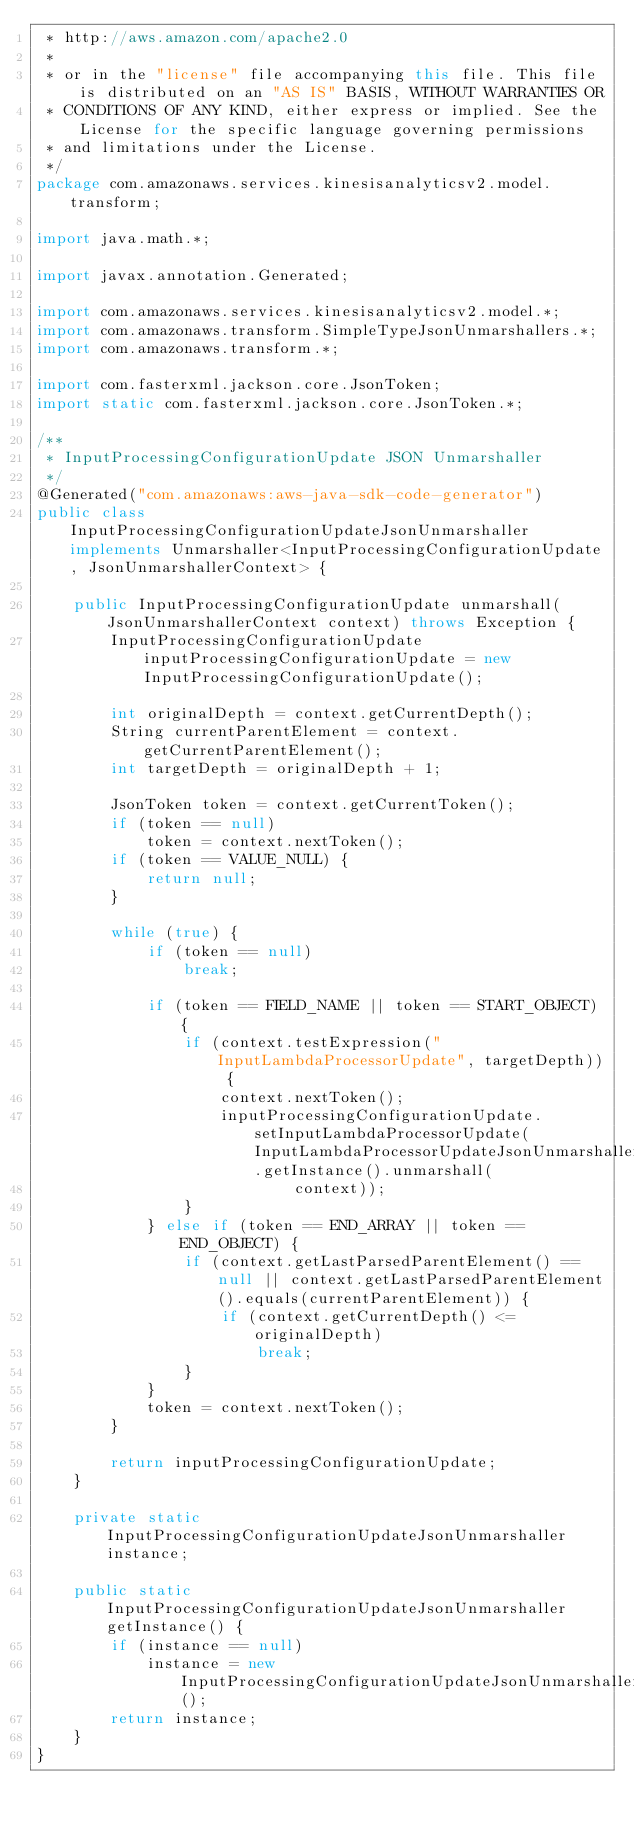Convert code to text. <code><loc_0><loc_0><loc_500><loc_500><_Java_> * http://aws.amazon.com/apache2.0
 * 
 * or in the "license" file accompanying this file. This file is distributed on an "AS IS" BASIS, WITHOUT WARRANTIES OR
 * CONDITIONS OF ANY KIND, either express or implied. See the License for the specific language governing permissions
 * and limitations under the License.
 */
package com.amazonaws.services.kinesisanalyticsv2.model.transform;

import java.math.*;

import javax.annotation.Generated;

import com.amazonaws.services.kinesisanalyticsv2.model.*;
import com.amazonaws.transform.SimpleTypeJsonUnmarshallers.*;
import com.amazonaws.transform.*;

import com.fasterxml.jackson.core.JsonToken;
import static com.fasterxml.jackson.core.JsonToken.*;

/**
 * InputProcessingConfigurationUpdate JSON Unmarshaller
 */
@Generated("com.amazonaws:aws-java-sdk-code-generator")
public class InputProcessingConfigurationUpdateJsonUnmarshaller implements Unmarshaller<InputProcessingConfigurationUpdate, JsonUnmarshallerContext> {

    public InputProcessingConfigurationUpdate unmarshall(JsonUnmarshallerContext context) throws Exception {
        InputProcessingConfigurationUpdate inputProcessingConfigurationUpdate = new InputProcessingConfigurationUpdate();

        int originalDepth = context.getCurrentDepth();
        String currentParentElement = context.getCurrentParentElement();
        int targetDepth = originalDepth + 1;

        JsonToken token = context.getCurrentToken();
        if (token == null)
            token = context.nextToken();
        if (token == VALUE_NULL) {
            return null;
        }

        while (true) {
            if (token == null)
                break;

            if (token == FIELD_NAME || token == START_OBJECT) {
                if (context.testExpression("InputLambdaProcessorUpdate", targetDepth)) {
                    context.nextToken();
                    inputProcessingConfigurationUpdate.setInputLambdaProcessorUpdate(InputLambdaProcessorUpdateJsonUnmarshaller.getInstance().unmarshall(
                            context));
                }
            } else if (token == END_ARRAY || token == END_OBJECT) {
                if (context.getLastParsedParentElement() == null || context.getLastParsedParentElement().equals(currentParentElement)) {
                    if (context.getCurrentDepth() <= originalDepth)
                        break;
                }
            }
            token = context.nextToken();
        }

        return inputProcessingConfigurationUpdate;
    }

    private static InputProcessingConfigurationUpdateJsonUnmarshaller instance;

    public static InputProcessingConfigurationUpdateJsonUnmarshaller getInstance() {
        if (instance == null)
            instance = new InputProcessingConfigurationUpdateJsonUnmarshaller();
        return instance;
    }
}
</code> 